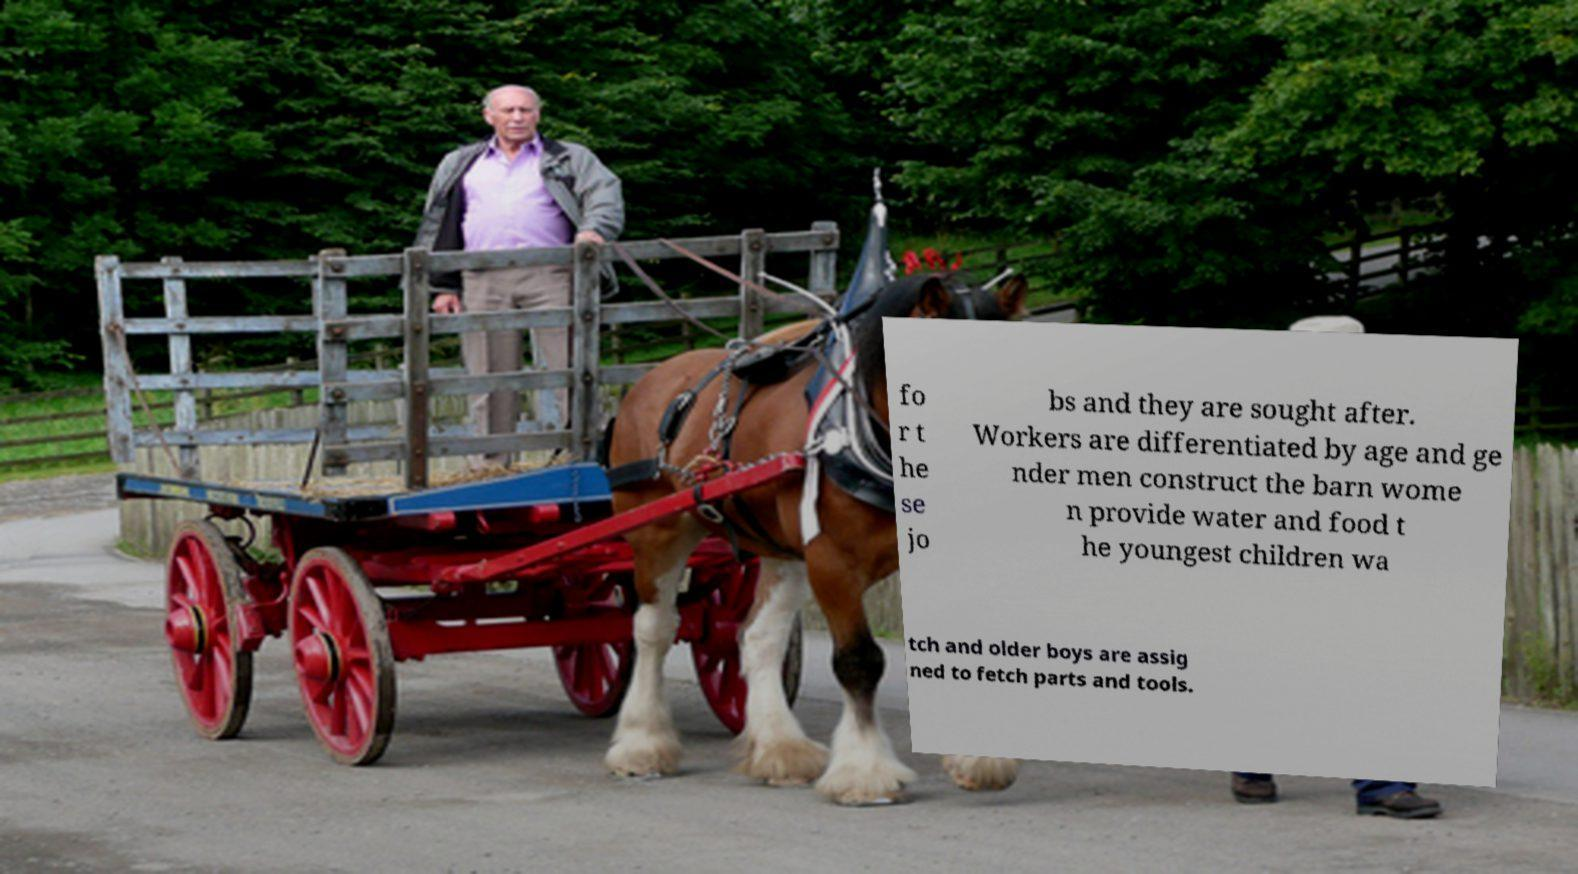There's text embedded in this image that I need extracted. Can you transcribe it verbatim? fo r t he se jo bs and they are sought after. Workers are differentiated by age and ge nder men construct the barn wome n provide water and food t he youngest children wa tch and older boys are assig ned to fetch parts and tools. 